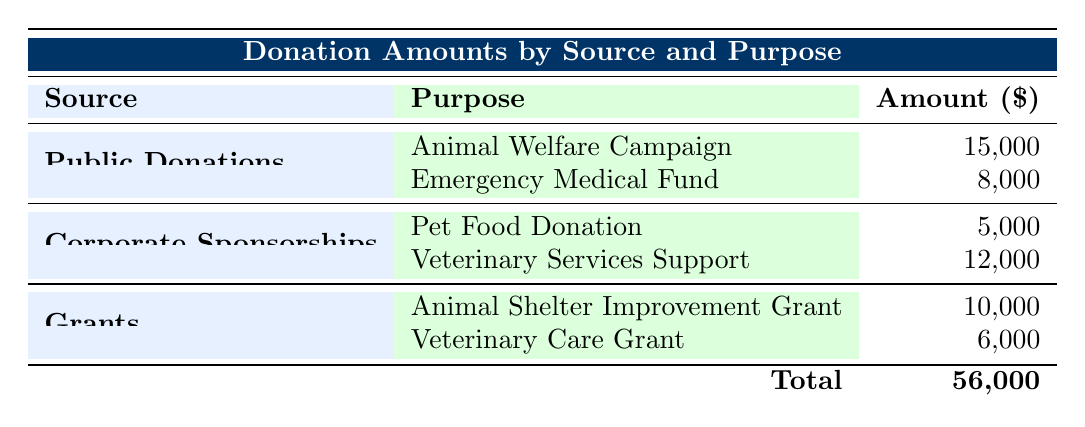What is the total amount of donations listed in the table? The total amount can be found at the bottom of the table. It sums up all the individual donation amounts across all the sources: 15,000 (Public Donations: Animal Welfare) + 8,000 (Public Donations: Emergency Medical Fund) + 5,000 (Corporate Sponsorships: Pet Food Donation) + 12,000 (Corporate Sponsorships: Veterinary Services Support) + 10,000 (Grants: Animal Shelter Improvement Grant) + 6,000 (Grants: Veterinary Care Grant) = 56,000.
Answer: 56,000 What is the purpose associated with the highest donation amount? To determine the highest donation amount, we can compare all the individual amounts listed in the table: 15,000 for the Animal Welfare Campaign, 8,000 for the Emergency Medical Fund, 5,000 for Pet Food Donation, 12,000 for Veterinary Services Support, 10,000 for the Animal Shelter Improvement Grant, and 6,000 for the Veterinary Care Grant. The highest is 15,000 for the Animal Welfare Campaign.
Answer: Animal Welfare Campaign Which source has a total donation amount that is greater than 10,000? Examining each source: Public Donations sums to 23,000 (15,000 + 8,000), Corporate Sponsorships sums to 17,000 (5,000 + 12,000), and Grants sums to 16,000 (10,000 + 6,000). The source "Public Donations" is the only one exceeding 10,000.
Answer: Public Donations Does Corporate Sponsorships have a donation purpose greater than 10,000? We need to check the amounts under Corporate Sponsorships: Pet Food Donation is 5,000 and Veterinary Services Support is 12,000. Since 12,000 is greater than 10,000, the answer is yes.
Answer: Yes What is the total amount received from animal-related grants? We identify the grant amounts in the table: Animal Shelter Improvement Grant is 10,000 and Veterinary Care Grant is 6,000. By adding these amounts, we find 10,000 + 6,000 = 16,000.
Answer: 16,000 Which donor contributed the least in the Animal Welfare Campaign? In the Animal Welfare Campaign, we identify the individual contributions: Linda Smith with 5,000, John Doe with 3,000, and Sarah Johnson with 2,000. The least contribution is 2,000 from Sarah Johnson.
Answer: Sarah Johnson Is the total amount of donations from grants less than 15,000? The total amount for grants can be calculated as 10,000 (Animal Shelter Improvement Grant) + 6,000 (Veterinary Care Grant) = 16,000. Since 16,000 is not less than 15,000, the answer is no.
Answer: No Which source contributed more to veterinary services, and what was that amount? We examine the purposes related to veterinary services within each source. Corporate Sponsorships contributed 12,000 to Veterinary Services Support. Public Donations and Grants do not have donations labeled specifically for veterinary services, so the highest amount is 12,000 from Corporate Sponsorships.
Answer: Corporate Sponsorships, 12,000 